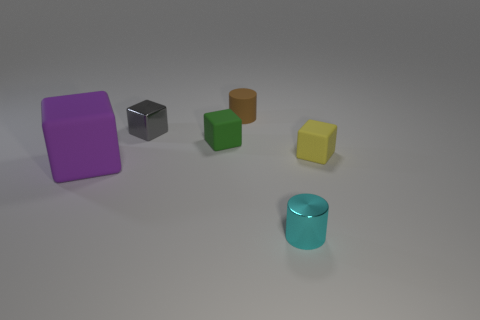Add 3 big purple cubes. How many objects exist? 9 Subtract all cubes. How many objects are left? 2 Subtract all small green metal balls. Subtract all small blocks. How many objects are left? 3 Add 3 tiny yellow cubes. How many tiny yellow cubes are left? 4 Add 4 big purple metal things. How many big purple metal things exist? 4 Subtract 1 green cubes. How many objects are left? 5 